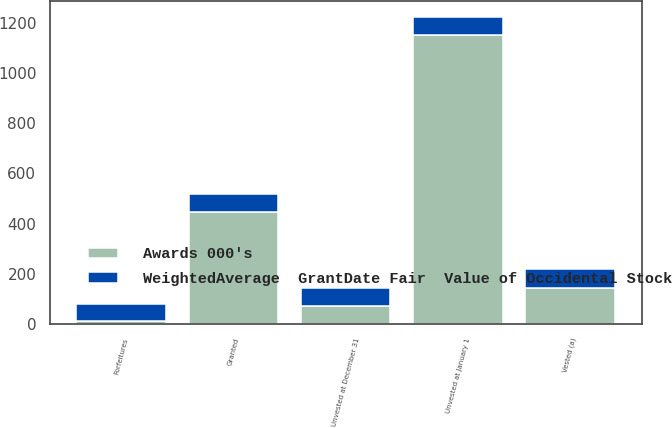Convert chart. <chart><loc_0><loc_0><loc_500><loc_500><stacked_bar_chart><ecel><fcel>Unvested at January 1<fcel>Granted<fcel>Vested (a)<fcel>Forfeitures<fcel>Unvested at December 31<nl><fcel>Awards 000's<fcel>1152<fcel>448<fcel>145<fcel>11<fcel>71.58<nl><fcel>WeightedAverage  GrantDate Fair  Value of Occidental Stock<fcel>71.58<fcel>69.87<fcel>72.54<fcel>69.87<fcel>70.97<nl></chart> 